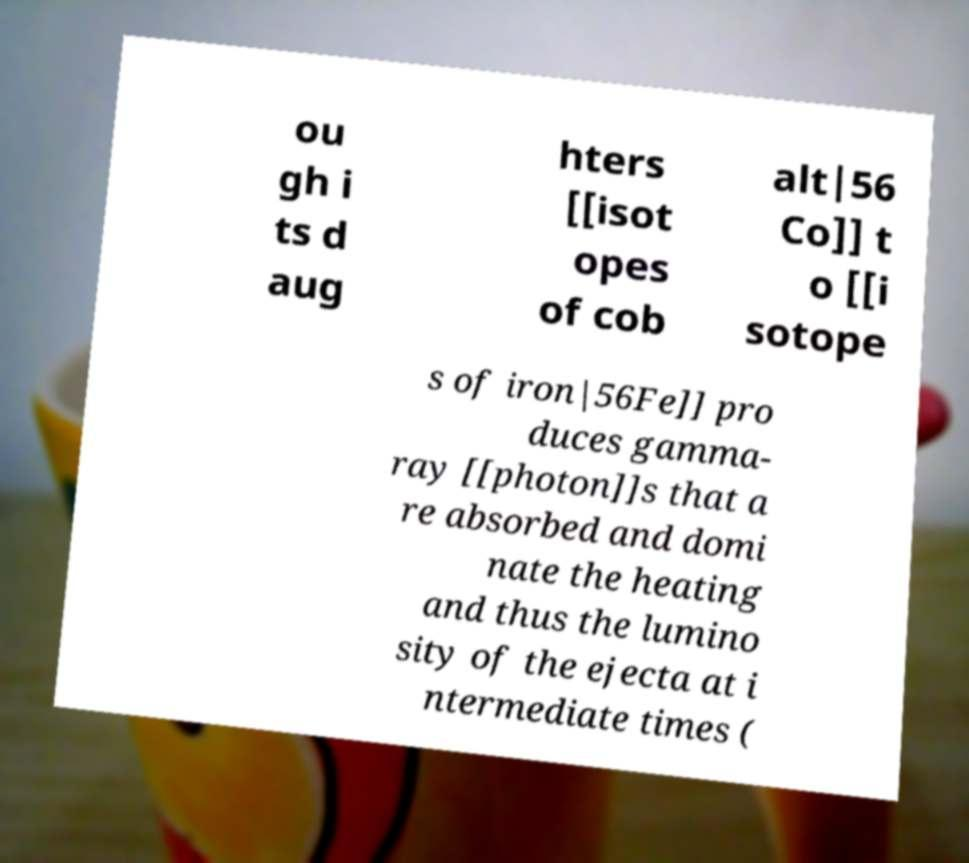There's text embedded in this image that I need extracted. Can you transcribe it verbatim? ou gh i ts d aug hters [[isot opes of cob alt|56 Co]] t o [[i sotope s of iron|56Fe]] pro duces gamma- ray [[photon]]s that a re absorbed and domi nate the heating and thus the lumino sity of the ejecta at i ntermediate times ( 